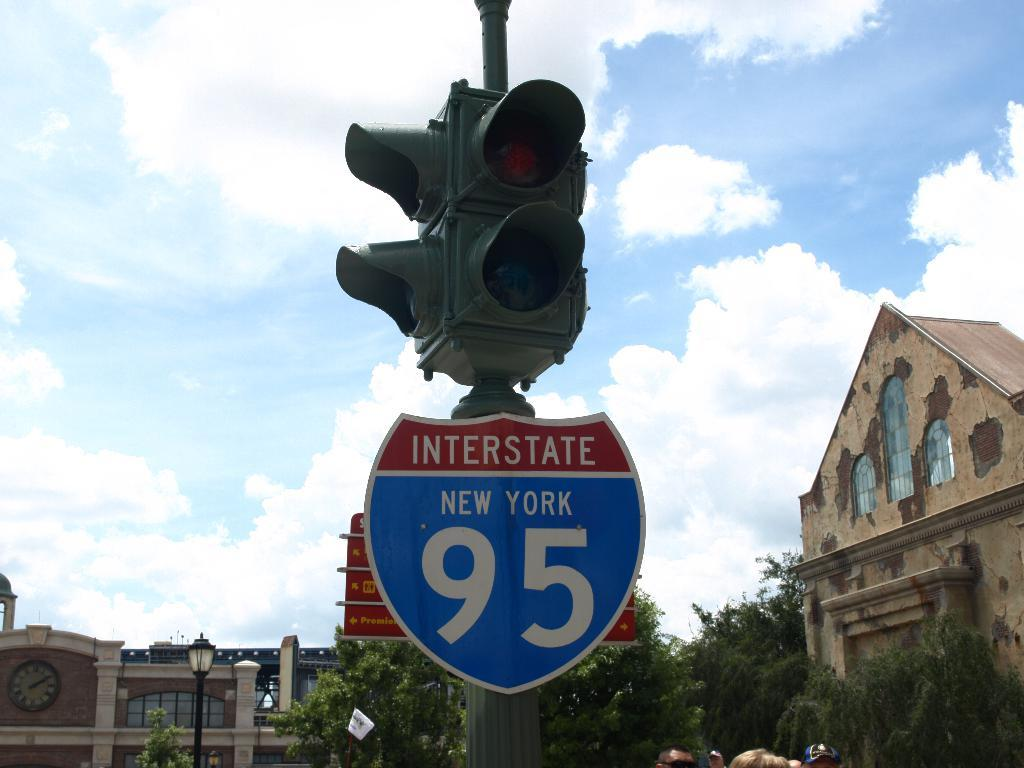<image>
Give a short and clear explanation of the subsequent image. A redlight with a sign for Interstate 95 in New York state. 